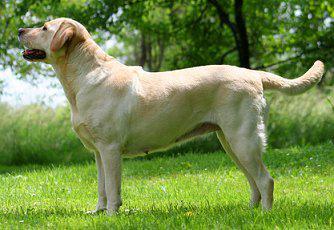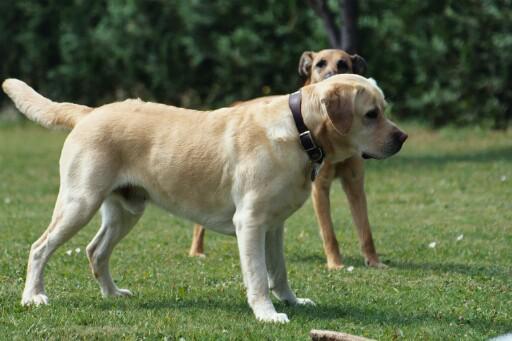The first image is the image on the left, the second image is the image on the right. For the images shown, is this caption "Images show foreground dogs in profile on grass with bodies in opposite directions." true? Answer yes or no. Yes. 